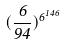Convert formula to latex. <formula><loc_0><loc_0><loc_500><loc_500>( \frac { 6 } { 9 4 } ) ^ { 6 ^ { 1 4 6 } }</formula> 